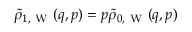Convert formula to latex. <formula><loc_0><loc_0><loc_500><loc_500>\tilde { \rho } _ { 1 , W } ( q , p ) = p \tilde { \rho } _ { 0 , W } ( q , p )</formula> 